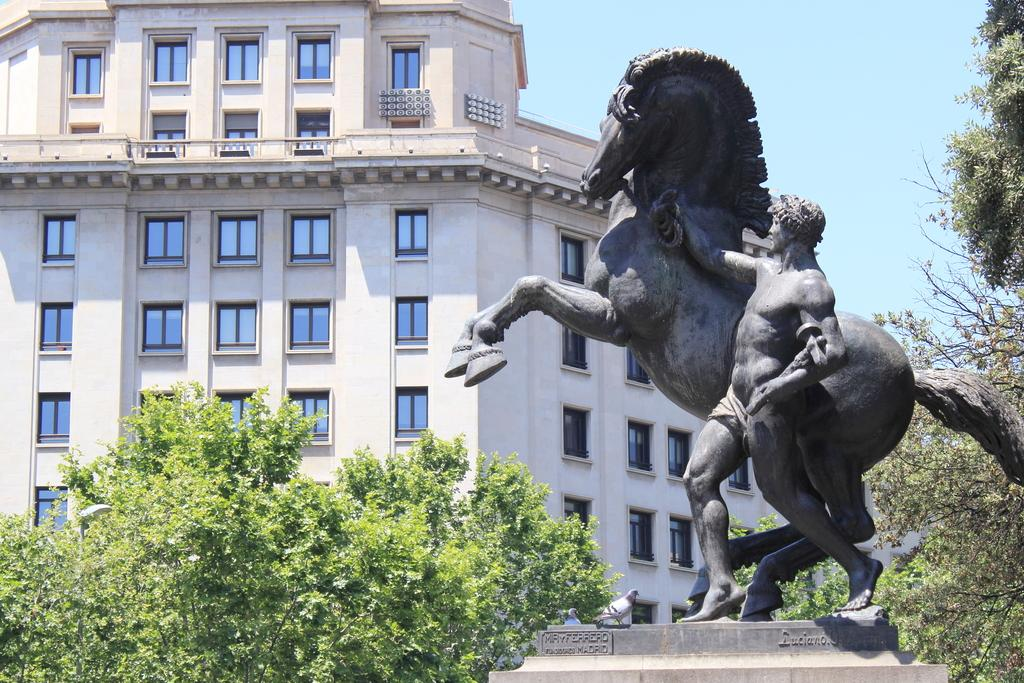What is the main subject of the image? The main subject of the image is a statue of a person and a horse. What can be seen in the background of the image? There is a building and trees in the background of the image. What is visible in the sky in the image? The sky is visible in the background of the image. What type of vessel is being used by the person on the horse in the image? There is no vessel present in the image, as it features a statue of a person and a horse. What ornament is hanging from the horse's neck in the image? There is no ornament hanging from the horse's neck in the image, as it is a statue. 